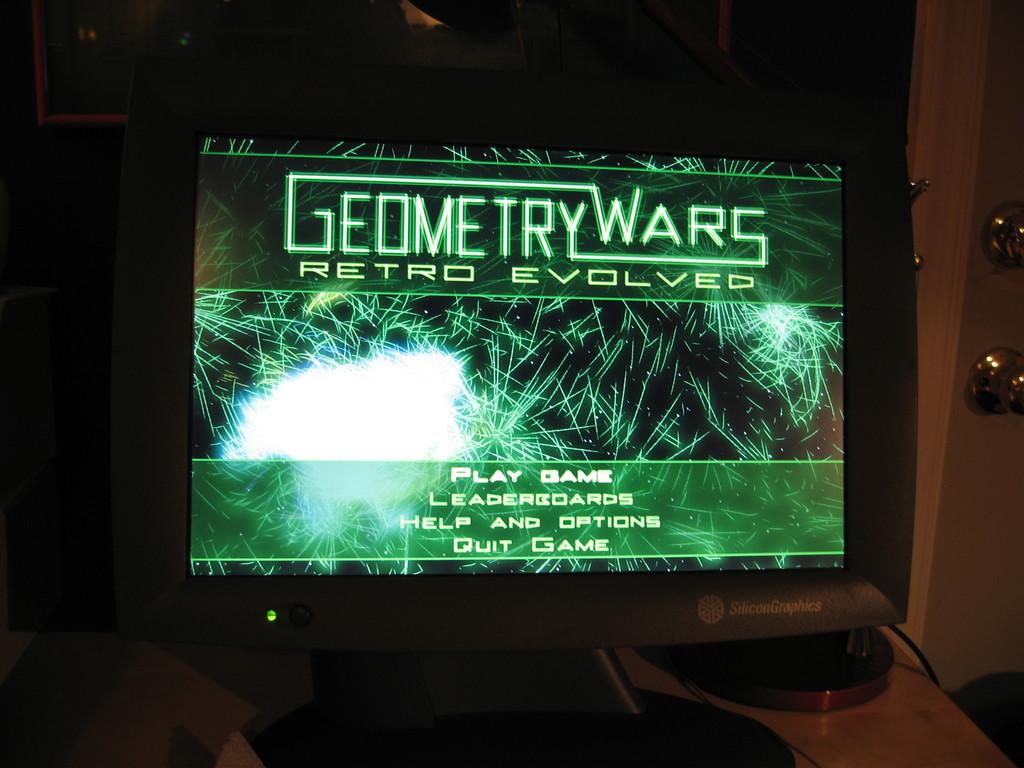What is the name of the game?
Offer a very short reply. Geometry wars. What is one of the options on the main screen?
Provide a succinct answer. Play game. 